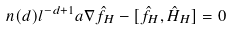<formula> <loc_0><loc_0><loc_500><loc_500>n ( d ) l ^ { - d + 1 } \sl a { \nabla } \hat { f } _ { H } - [ \hat { f } _ { H } , \hat { H } _ { H } ] = 0</formula> 